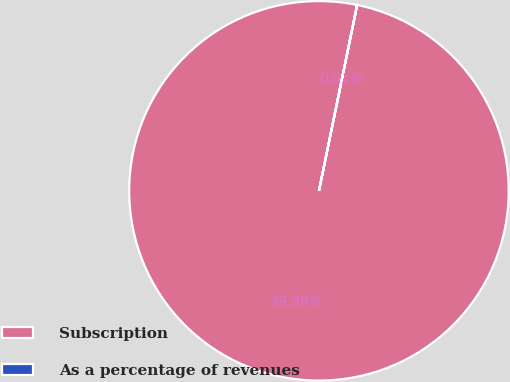Convert chart to OTSL. <chart><loc_0><loc_0><loc_500><loc_500><pie_chart><fcel>Subscription<fcel>As a percentage of revenues<nl><fcel>99.99%<fcel>0.01%<nl></chart> 